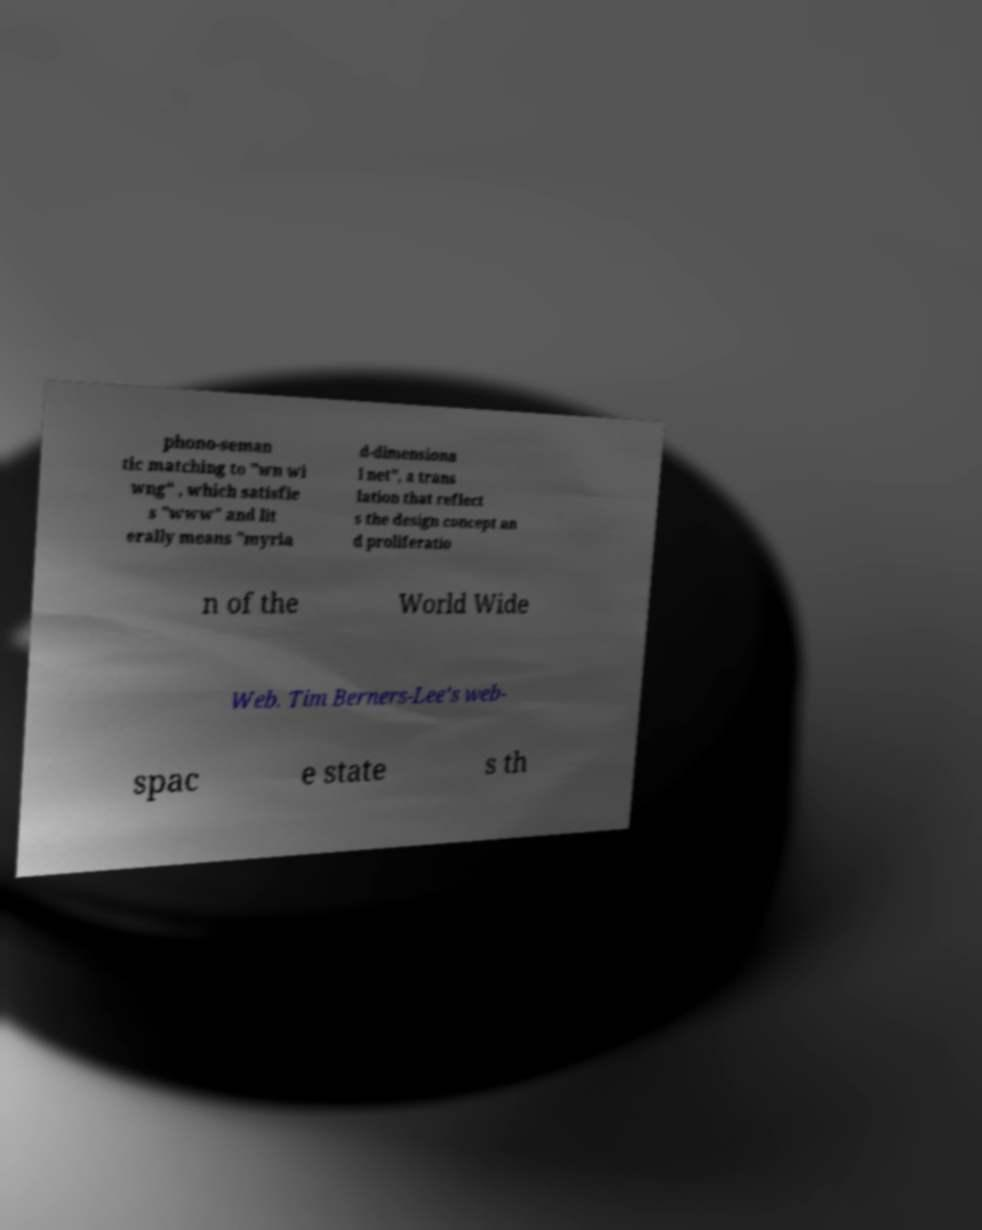Can you accurately transcribe the text from the provided image for me? phono-seman tic matching to "wn wi wng" , which satisfie s "www" and lit erally means "myria d-dimensiona l net", a trans lation that reflect s the design concept an d proliferatio n of the World Wide Web. Tim Berners-Lee's web- spac e state s th 